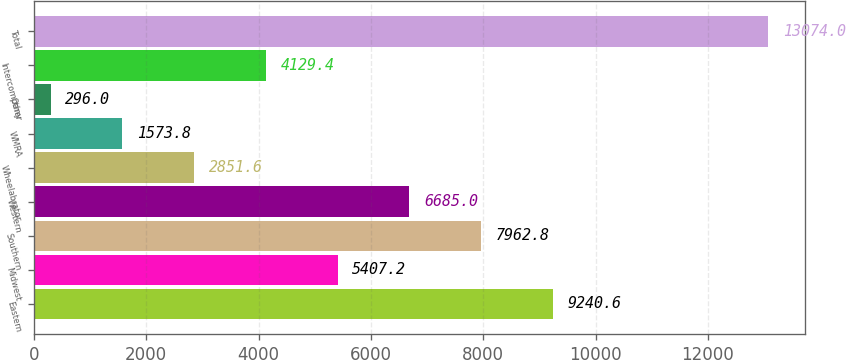Convert chart. <chart><loc_0><loc_0><loc_500><loc_500><bar_chart><fcel>Eastern<fcel>Midwest<fcel>Southern<fcel>Western<fcel>Wheelabrator<fcel>WMRA<fcel>Other<fcel>Intercompany<fcel>Total<nl><fcel>9240.6<fcel>5407.2<fcel>7962.8<fcel>6685<fcel>2851.6<fcel>1573.8<fcel>296<fcel>4129.4<fcel>13074<nl></chart> 